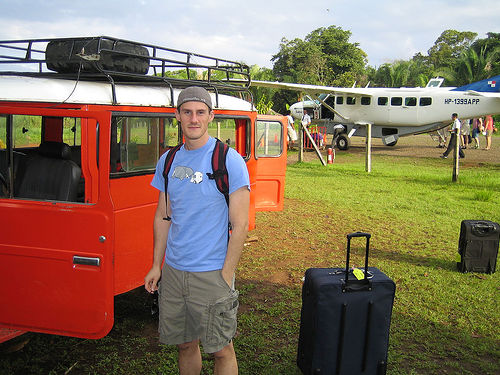<image>
Can you confirm if the bag is behind the man? No. The bag is not behind the man. From this viewpoint, the bag appears to be positioned elsewhere in the scene. Is there a jeep in front of the man? No. The jeep is not in front of the man. The spatial positioning shows a different relationship between these objects. 